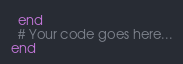<code> <loc_0><loc_0><loc_500><loc_500><_Ruby_>  end
  # Your code goes here...
end
</code> 